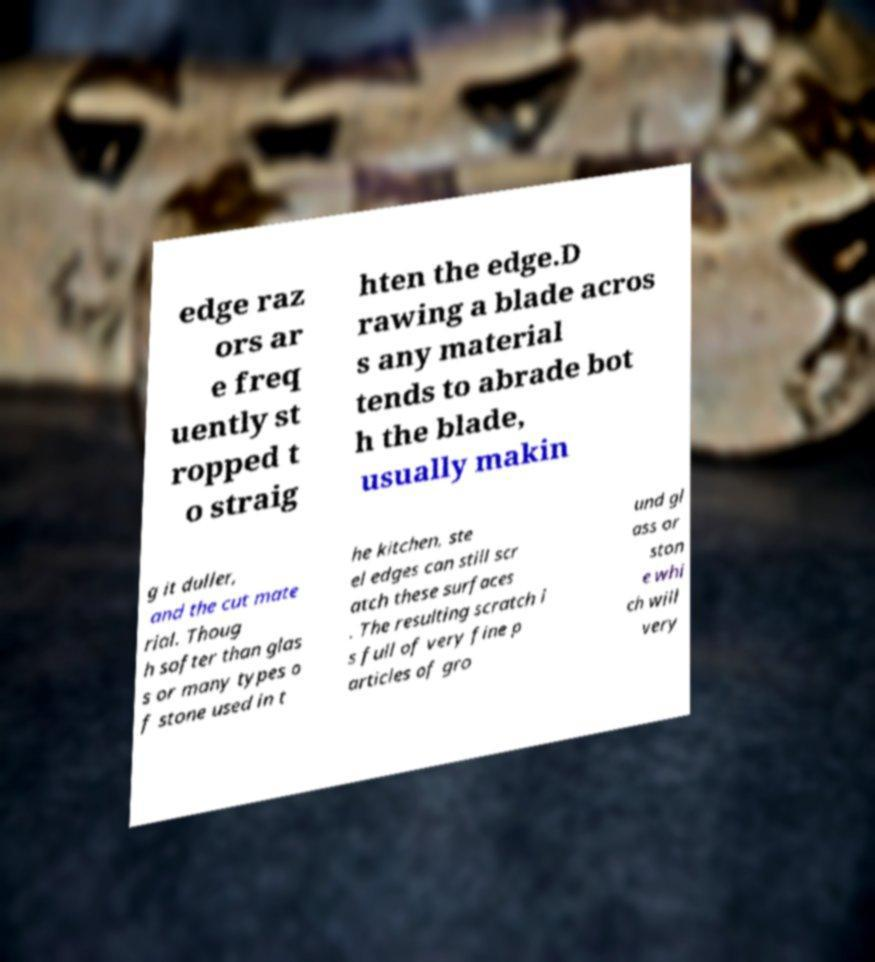Could you assist in decoding the text presented in this image and type it out clearly? edge raz ors ar e freq uently st ropped t o straig hten the edge.D rawing a blade acros s any material tends to abrade bot h the blade, usually makin g it duller, and the cut mate rial. Thoug h softer than glas s or many types o f stone used in t he kitchen, ste el edges can still scr atch these surfaces . The resulting scratch i s full of very fine p articles of gro und gl ass or ston e whi ch will very 